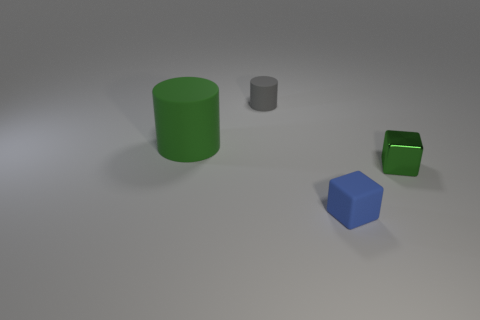Add 2 large purple cylinders. How many objects exist? 6 Add 3 big green objects. How many big green objects exist? 4 Subtract 0 purple cubes. How many objects are left? 4 Subtract all big brown rubber balls. Subtract all small blocks. How many objects are left? 2 Add 3 tiny blue things. How many tiny blue things are left? 4 